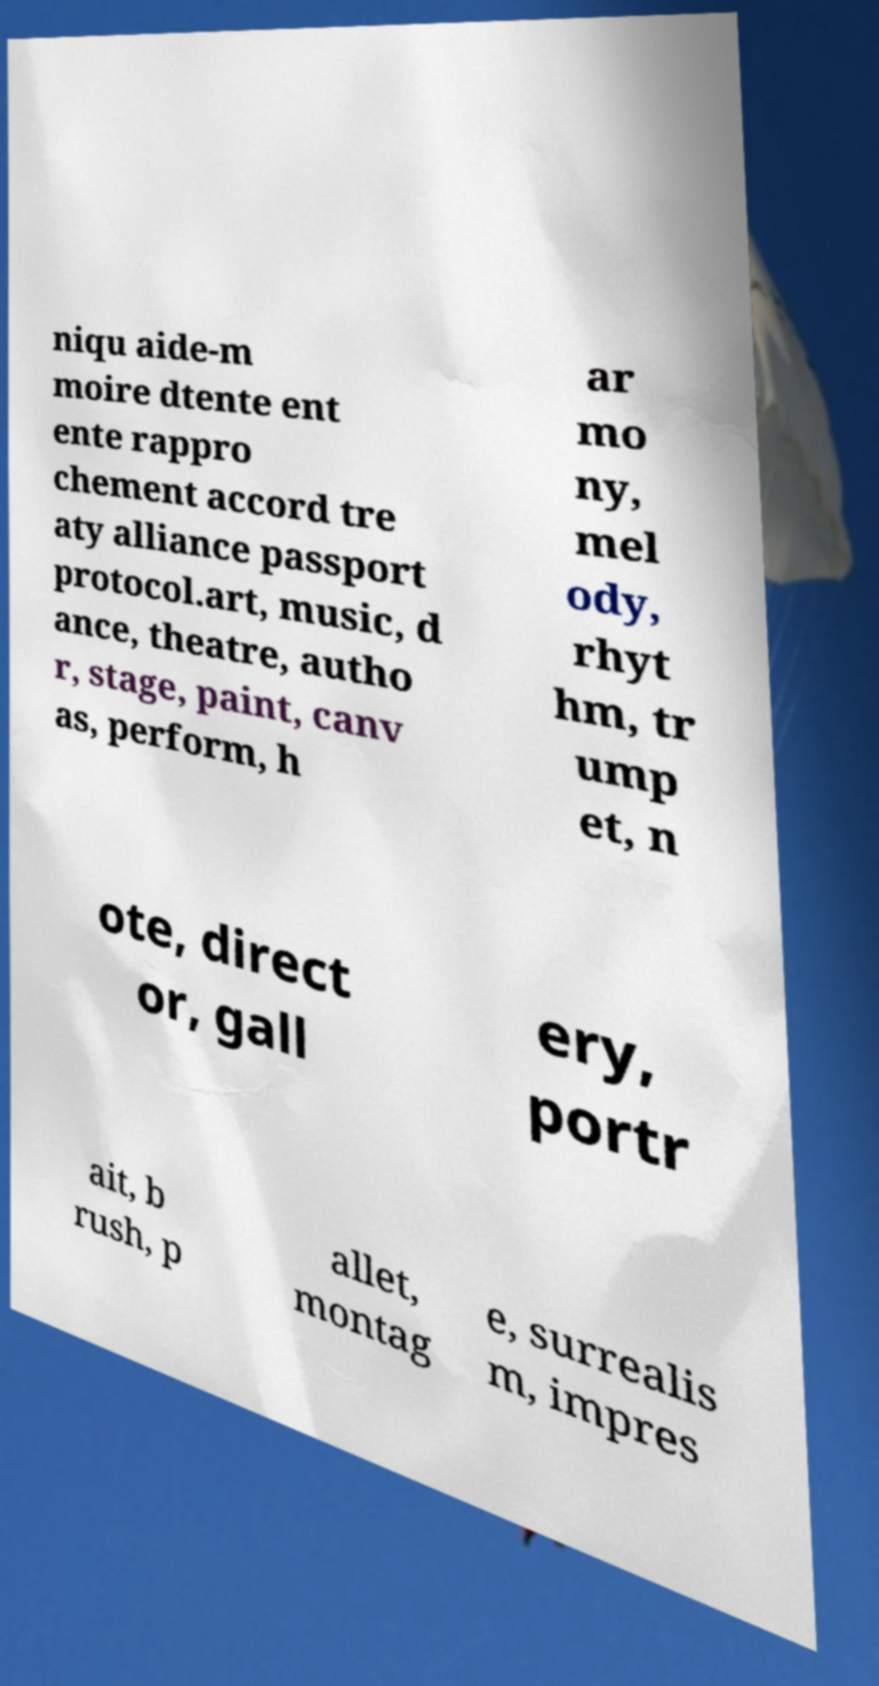Could you assist in decoding the text presented in this image and type it out clearly? niqu aide-m moire dtente ent ente rappro chement accord tre aty alliance passport protocol.art, music, d ance, theatre, autho r, stage, paint, canv as, perform, h ar mo ny, mel ody, rhyt hm, tr ump et, n ote, direct or, gall ery, portr ait, b rush, p allet, montag e, surrealis m, impres 